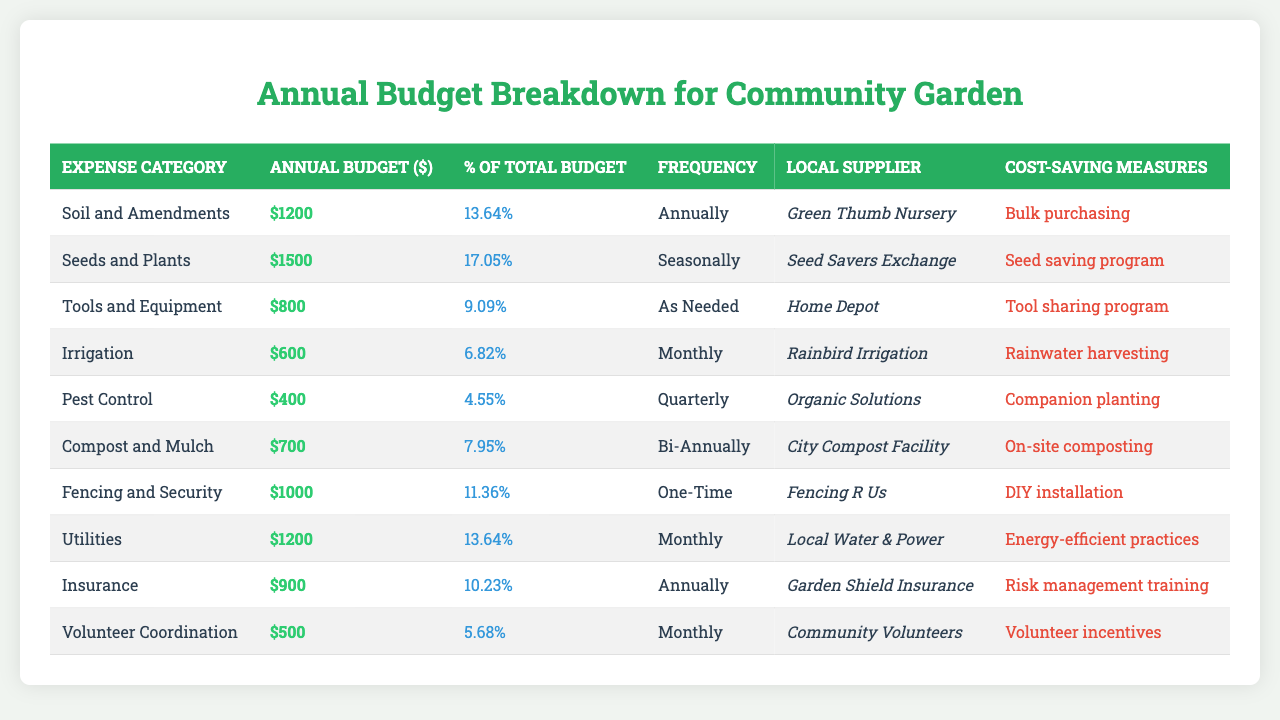What is the highest annual budget for a single expense category? The highest annual budget can be found by comparing the values in the "Annual Budget ($)" column. The maximum value is 1500, which corresponds to "Seeds and Plants."
Answer: 1500 Which expense category has the lowest percentage of total budget? The lowest percentage can be identified by looking at the "Percentage of Total Budget" column. The minimum value is 4.55%, which is associated with "Pest Control."
Answer: 4.55% How much does the community garden spend annually on irrigation? From the "Annual Budget ($)" column, the budget allocated for irrigation is 600.
Answer: 600 What is the combined annual budget for all utility-related expenses? The total for utilities can be found by retrieving the budget values for any relevant categories (only "Utilities" has mention here). Thus, the total is 1200.
Answer: 1200 How often are pest control expenses incurred? The frequency of pest control expenses is listed under the "Frequency of Expense" and is noted as "Quarterly."
Answer: Quarterly What is the average budget across all expense categories? To find the average, sum all the annual budgets (1200 + 1500 + 800 + 600 + 400 + 700 + 1000 + 1200 + 900 + 500 = 6100) and divide by the number of categories (10), yielding an average of 610.
Answer: 610 Are there any expense categories that are one-time expenses? Checking the "Frequency of Expense," the only one-time expense category is "Fencing and Security."
Answer: Yes Which local supplier is listed for soil and amendments? The "Local Supplier" for "Soil and Amendments" can be found in the corresponding row, which is "Green Thumb Nursery."
Answer: Green Thumb Nursery What percentage of the total budget is allocated to tools and equipment? The "Percentage of Total Budget" for "Tools and Equipment" is 9.09%.
Answer: 9.09% If all potential cost-saving measures are implemented, what might the community garden save on pest control? The potential cost-saving measure listed for pest control is "Companion planting," and while savings are not quantified, the budget for pest control itself is 400. Thus, cost-saving could imply reduced expenditure, but specifics on savings are not given.
Answer: Not quantifiable, savings implied Which expense category has a frequency of "Bi-Annually"? Reviewing the "Frequency of Expense" column, "Compost and Mulch" is listed with a frequency of "Bi-Annually."
Answer: Compost and Mulch What is the total annual budget for expenses that occur monthly? The monthly expenses are listed as "Irrigation" (600), "Utilities" (1200), and "Volunteer Coordination" (500). The total is 600 + 1200 + 500 = 2300.
Answer: 2300 Is insurance among the top three most significant expenses? By checking the "Annual Budget ($)" values, we find that the budget for "Insurance" (900) does not rank in the top three, as "Seeds and Plants," "Soil and Amendments," and "Tools and Equipment" (1500, 1200, and 800 respectively) surpass it.
Answer: No Which expense category is associated with the highest potential cost-saving measure? The potential cost-saving measures are ranked qualitatively rather than quantitatively, but if we look at their implications, "Bulk purchasing" could represent a significant potential saving when applied broadly to "Soil and Amendments," which has the highest budget.
Answer: Bulk purchasing (associated with Soil and Amendments) 